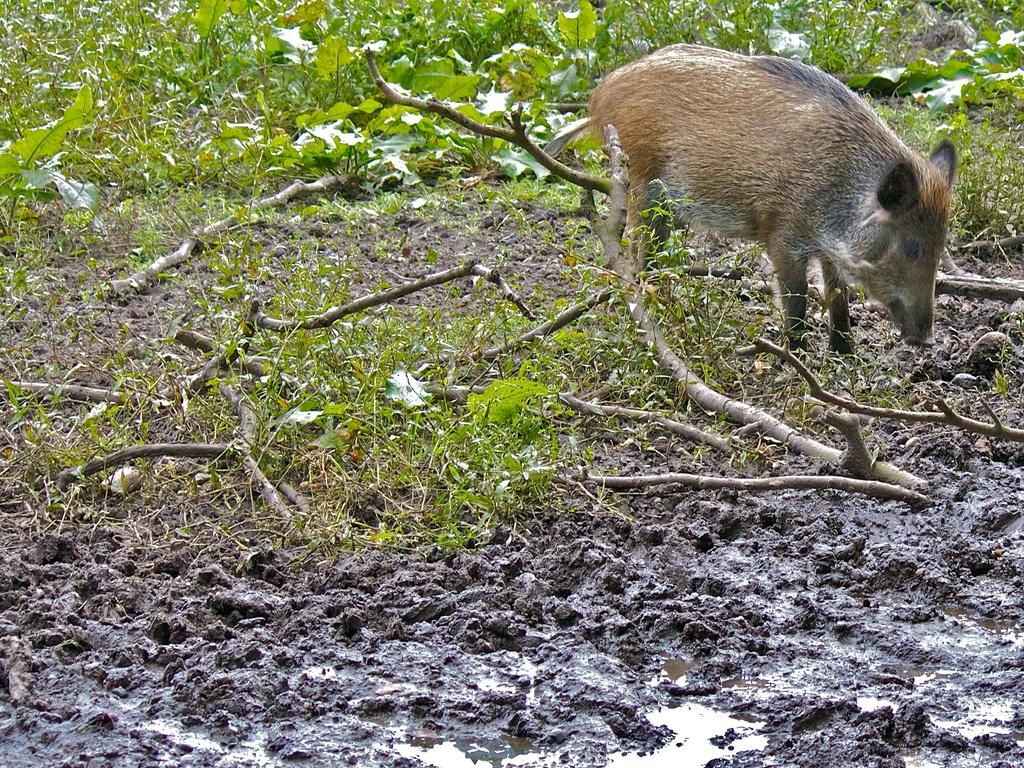What animal is present in the image? There is a pig in the image. Where is the pig located? The pig is standing on the land. What can be found on the land besides the pig? There are plants and wooden trunks on the land. How many women are holding the pig in the image? There are no women present in the image, and the pig is standing on its own. 